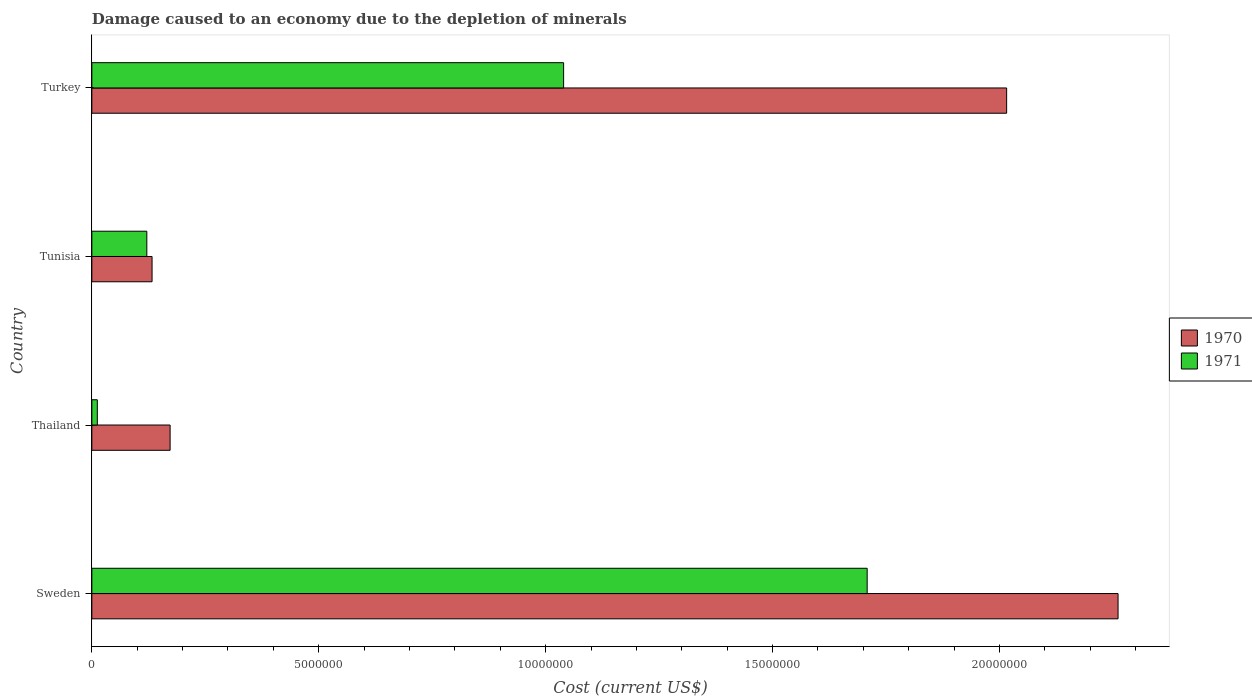How many different coloured bars are there?
Your answer should be compact. 2. How many groups of bars are there?
Give a very brief answer. 4. Are the number of bars per tick equal to the number of legend labels?
Make the answer very short. Yes. Are the number of bars on each tick of the Y-axis equal?
Your answer should be compact. Yes. How many bars are there on the 2nd tick from the top?
Provide a short and direct response. 2. What is the label of the 2nd group of bars from the top?
Provide a short and direct response. Tunisia. In how many cases, is the number of bars for a given country not equal to the number of legend labels?
Your response must be concise. 0. What is the cost of damage caused due to the depletion of minerals in 1970 in Tunisia?
Offer a very short reply. 1.33e+06. Across all countries, what is the maximum cost of damage caused due to the depletion of minerals in 1970?
Your answer should be very brief. 2.26e+07. Across all countries, what is the minimum cost of damage caused due to the depletion of minerals in 1970?
Offer a very short reply. 1.33e+06. In which country was the cost of damage caused due to the depletion of minerals in 1970 maximum?
Offer a very short reply. Sweden. In which country was the cost of damage caused due to the depletion of minerals in 1970 minimum?
Offer a very short reply. Tunisia. What is the total cost of damage caused due to the depletion of minerals in 1970 in the graph?
Provide a succinct answer. 4.58e+07. What is the difference between the cost of damage caused due to the depletion of minerals in 1971 in Sweden and that in Tunisia?
Keep it short and to the point. 1.59e+07. What is the difference between the cost of damage caused due to the depletion of minerals in 1971 in Sweden and the cost of damage caused due to the depletion of minerals in 1970 in Tunisia?
Make the answer very short. 1.58e+07. What is the average cost of damage caused due to the depletion of minerals in 1970 per country?
Offer a very short reply. 1.15e+07. What is the difference between the cost of damage caused due to the depletion of minerals in 1971 and cost of damage caused due to the depletion of minerals in 1970 in Thailand?
Ensure brevity in your answer.  -1.60e+06. In how many countries, is the cost of damage caused due to the depletion of minerals in 1970 greater than 6000000 US$?
Offer a very short reply. 2. What is the ratio of the cost of damage caused due to the depletion of minerals in 1970 in Sweden to that in Turkey?
Provide a succinct answer. 1.12. Is the difference between the cost of damage caused due to the depletion of minerals in 1971 in Thailand and Tunisia greater than the difference between the cost of damage caused due to the depletion of minerals in 1970 in Thailand and Tunisia?
Offer a terse response. No. What is the difference between the highest and the second highest cost of damage caused due to the depletion of minerals in 1971?
Your response must be concise. 6.69e+06. What is the difference between the highest and the lowest cost of damage caused due to the depletion of minerals in 1971?
Give a very brief answer. 1.70e+07. In how many countries, is the cost of damage caused due to the depletion of minerals in 1971 greater than the average cost of damage caused due to the depletion of minerals in 1971 taken over all countries?
Your response must be concise. 2. Is the sum of the cost of damage caused due to the depletion of minerals in 1971 in Sweden and Turkey greater than the maximum cost of damage caused due to the depletion of minerals in 1970 across all countries?
Ensure brevity in your answer.  Yes. How many bars are there?
Make the answer very short. 8. Are all the bars in the graph horizontal?
Provide a succinct answer. Yes. What is the difference between two consecutive major ticks on the X-axis?
Your answer should be compact. 5.00e+06. Are the values on the major ticks of X-axis written in scientific E-notation?
Your answer should be compact. No. Where does the legend appear in the graph?
Provide a succinct answer. Center right. How many legend labels are there?
Provide a short and direct response. 2. What is the title of the graph?
Keep it short and to the point. Damage caused to an economy due to the depletion of minerals. Does "1980" appear as one of the legend labels in the graph?
Ensure brevity in your answer.  No. What is the label or title of the X-axis?
Offer a terse response. Cost (current US$). What is the Cost (current US$) of 1970 in Sweden?
Make the answer very short. 2.26e+07. What is the Cost (current US$) in 1971 in Sweden?
Your answer should be very brief. 1.71e+07. What is the Cost (current US$) of 1970 in Thailand?
Make the answer very short. 1.72e+06. What is the Cost (current US$) in 1971 in Thailand?
Give a very brief answer. 1.21e+05. What is the Cost (current US$) in 1970 in Tunisia?
Provide a succinct answer. 1.33e+06. What is the Cost (current US$) of 1971 in Tunisia?
Offer a terse response. 1.21e+06. What is the Cost (current US$) in 1970 in Turkey?
Your answer should be very brief. 2.02e+07. What is the Cost (current US$) of 1971 in Turkey?
Offer a terse response. 1.04e+07. Across all countries, what is the maximum Cost (current US$) in 1970?
Keep it short and to the point. 2.26e+07. Across all countries, what is the maximum Cost (current US$) of 1971?
Provide a short and direct response. 1.71e+07. Across all countries, what is the minimum Cost (current US$) of 1970?
Offer a very short reply. 1.33e+06. Across all countries, what is the minimum Cost (current US$) of 1971?
Your answer should be very brief. 1.21e+05. What is the total Cost (current US$) in 1970 in the graph?
Give a very brief answer. 4.58e+07. What is the total Cost (current US$) in 1971 in the graph?
Give a very brief answer. 2.88e+07. What is the difference between the Cost (current US$) in 1970 in Sweden and that in Thailand?
Provide a short and direct response. 2.09e+07. What is the difference between the Cost (current US$) of 1971 in Sweden and that in Thailand?
Keep it short and to the point. 1.70e+07. What is the difference between the Cost (current US$) of 1970 in Sweden and that in Tunisia?
Provide a succinct answer. 2.13e+07. What is the difference between the Cost (current US$) in 1971 in Sweden and that in Tunisia?
Give a very brief answer. 1.59e+07. What is the difference between the Cost (current US$) in 1970 in Sweden and that in Turkey?
Your answer should be compact. 2.46e+06. What is the difference between the Cost (current US$) in 1971 in Sweden and that in Turkey?
Your response must be concise. 6.69e+06. What is the difference between the Cost (current US$) in 1970 in Thailand and that in Tunisia?
Provide a succinct answer. 3.98e+05. What is the difference between the Cost (current US$) of 1971 in Thailand and that in Tunisia?
Provide a succinct answer. -1.09e+06. What is the difference between the Cost (current US$) in 1970 in Thailand and that in Turkey?
Provide a short and direct response. -1.84e+07. What is the difference between the Cost (current US$) of 1971 in Thailand and that in Turkey?
Your answer should be compact. -1.03e+07. What is the difference between the Cost (current US$) in 1970 in Tunisia and that in Turkey?
Offer a very short reply. -1.88e+07. What is the difference between the Cost (current US$) in 1971 in Tunisia and that in Turkey?
Your answer should be compact. -9.18e+06. What is the difference between the Cost (current US$) in 1970 in Sweden and the Cost (current US$) in 1971 in Thailand?
Keep it short and to the point. 2.25e+07. What is the difference between the Cost (current US$) of 1970 in Sweden and the Cost (current US$) of 1971 in Tunisia?
Make the answer very short. 2.14e+07. What is the difference between the Cost (current US$) in 1970 in Sweden and the Cost (current US$) in 1971 in Turkey?
Your answer should be compact. 1.22e+07. What is the difference between the Cost (current US$) in 1970 in Thailand and the Cost (current US$) in 1971 in Tunisia?
Your response must be concise. 5.13e+05. What is the difference between the Cost (current US$) of 1970 in Thailand and the Cost (current US$) of 1971 in Turkey?
Offer a very short reply. -8.67e+06. What is the difference between the Cost (current US$) of 1970 in Tunisia and the Cost (current US$) of 1971 in Turkey?
Ensure brevity in your answer.  -9.07e+06. What is the average Cost (current US$) in 1970 per country?
Offer a very short reply. 1.15e+07. What is the average Cost (current US$) in 1971 per country?
Your answer should be compact. 7.20e+06. What is the difference between the Cost (current US$) of 1970 and Cost (current US$) of 1971 in Sweden?
Keep it short and to the point. 5.53e+06. What is the difference between the Cost (current US$) of 1970 and Cost (current US$) of 1971 in Thailand?
Make the answer very short. 1.60e+06. What is the difference between the Cost (current US$) in 1970 and Cost (current US$) in 1971 in Tunisia?
Your answer should be very brief. 1.16e+05. What is the difference between the Cost (current US$) in 1970 and Cost (current US$) in 1971 in Turkey?
Offer a terse response. 9.76e+06. What is the ratio of the Cost (current US$) in 1970 in Sweden to that in Thailand?
Your response must be concise. 13.11. What is the ratio of the Cost (current US$) in 1971 in Sweden to that in Thailand?
Offer a terse response. 141.73. What is the ratio of the Cost (current US$) of 1970 in Sweden to that in Tunisia?
Offer a very short reply. 17.04. What is the ratio of the Cost (current US$) in 1971 in Sweden to that in Tunisia?
Ensure brevity in your answer.  14.1. What is the ratio of the Cost (current US$) of 1970 in Sweden to that in Turkey?
Your answer should be compact. 1.12. What is the ratio of the Cost (current US$) of 1971 in Sweden to that in Turkey?
Your response must be concise. 1.64. What is the ratio of the Cost (current US$) of 1970 in Thailand to that in Tunisia?
Make the answer very short. 1.3. What is the ratio of the Cost (current US$) of 1971 in Thailand to that in Tunisia?
Give a very brief answer. 0.1. What is the ratio of the Cost (current US$) of 1970 in Thailand to that in Turkey?
Provide a short and direct response. 0.09. What is the ratio of the Cost (current US$) of 1971 in Thailand to that in Turkey?
Your answer should be very brief. 0.01. What is the ratio of the Cost (current US$) of 1970 in Tunisia to that in Turkey?
Ensure brevity in your answer.  0.07. What is the ratio of the Cost (current US$) in 1971 in Tunisia to that in Turkey?
Ensure brevity in your answer.  0.12. What is the difference between the highest and the second highest Cost (current US$) in 1970?
Your response must be concise. 2.46e+06. What is the difference between the highest and the second highest Cost (current US$) in 1971?
Offer a terse response. 6.69e+06. What is the difference between the highest and the lowest Cost (current US$) of 1970?
Offer a terse response. 2.13e+07. What is the difference between the highest and the lowest Cost (current US$) in 1971?
Your answer should be very brief. 1.70e+07. 